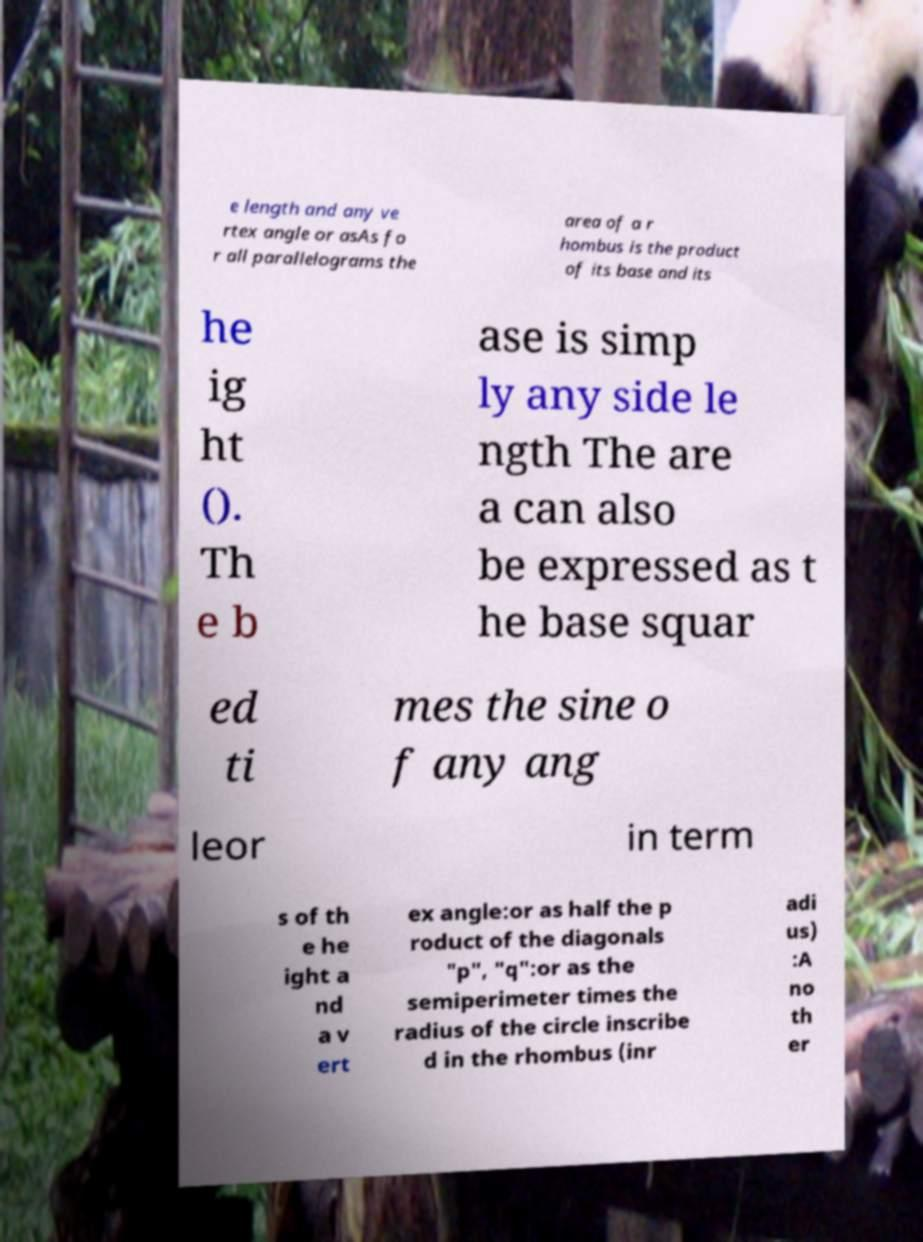What messages or text are displayed in this image? I need them in a readable, typed format. e length and any ve rtex angle or asAs fo r all parallelograms the area of a r hombus is the product of its base and its he ig ht (). Th e b ase is simp ly any side le ngth The are a can also be expressed as t he base squar ed ti mes the sine o f any ang leor in term s of th e he ight a nd a v ert ex angle:or as half the p roduct of the diagonals "p", "q":or as the semiperimeter times the radius of the circle inscribe d in the rhombus (inr adi us) :A no th er 